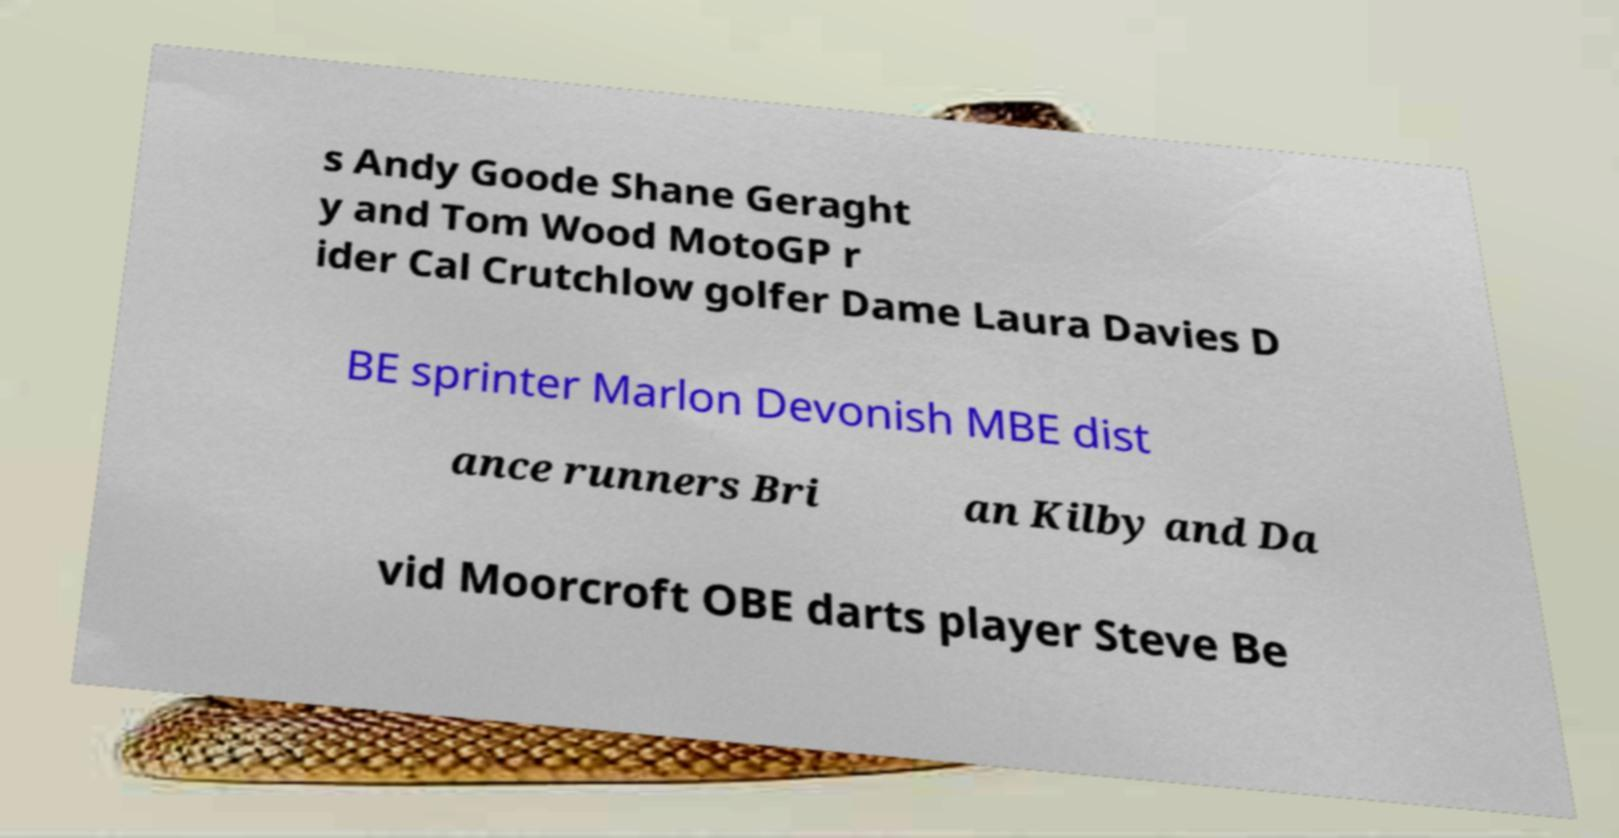What messages or text are displayed in this image? I need them in a readable, typed format. s Andy Goode Shane Geraght y and Tom Wood MotoGP r ider Cal Crutchlow golfer Dame Laura Davies D BE sprinter Marlon Devonish MBE dist ance runners Bri an Kilby and Da vid Moorcroft OBE darts player Steve Be 